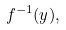Convert formula to latex. <formula><loc_0><loc_0><loc_500><loc_500>f ^ { - 1 } ( y ) ,</formula> 